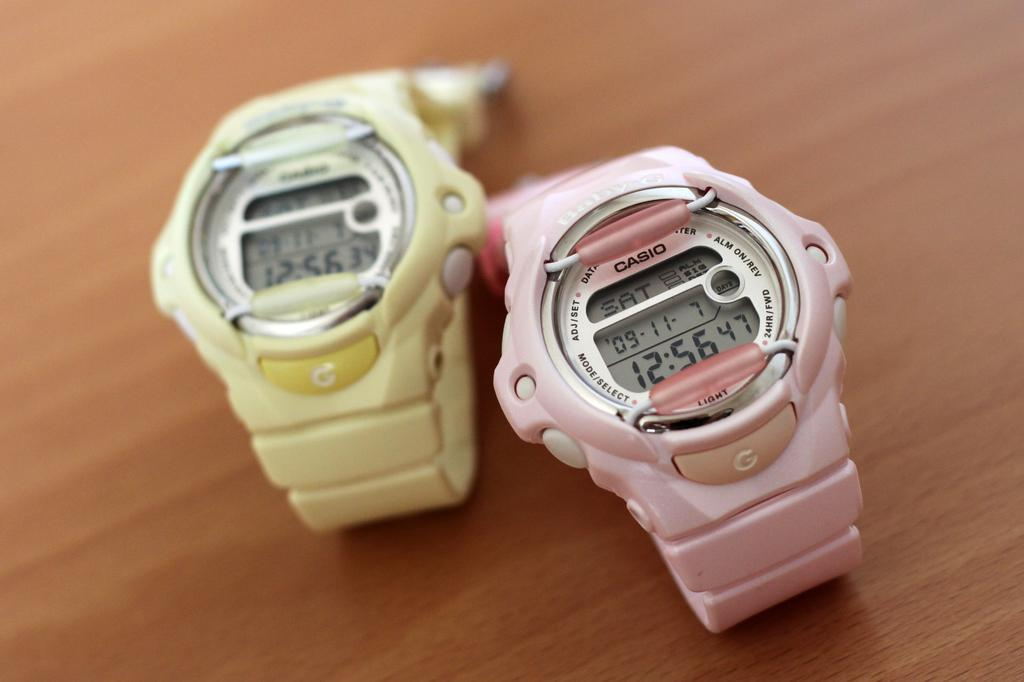<image>
Give a short and clear explanation of the subsequent image. A pink watch with the word CASIO printed on it. 